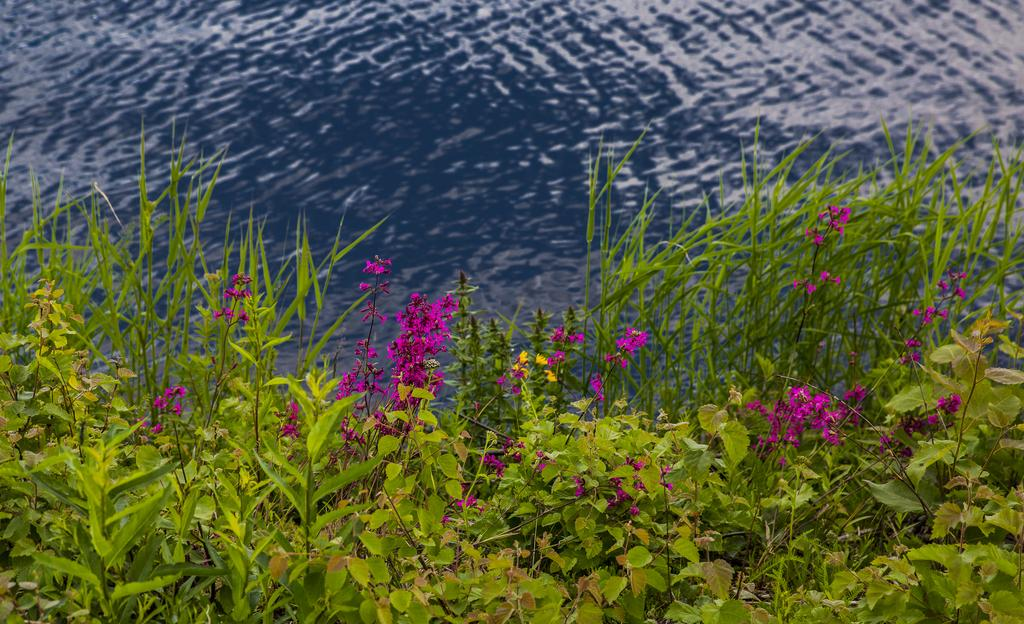What type of vegetation can be seen in the image? There are plants in the image. What is on the ground beneath the plants? There is grass on the ground in the image. Do the plants have any distinguishing features? Yes, the plants have flowers. What can be seen behind the plants? There is water visible behind the plants. Where is the group of rocks located in the image? There are no rocks present in the image. 